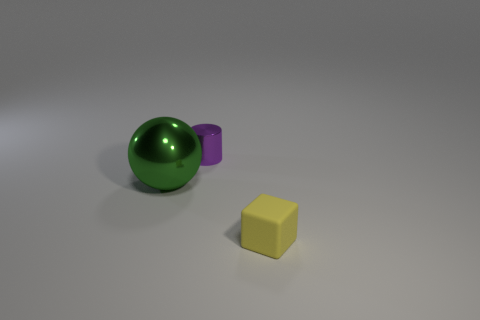Are there any other things that are the same shape as the big thing?
Your answer should be very brief. No. Are there fewer yellow matte objects that are behind the purple shiny cylinder than small green rubber spheres?
Ensure brevity in your answer.  No. How many small green objects are there?
Your answer should be very brief. 0. What number of big balls have the same material as the tiny purple thing?
Provide a succinct answer. 1. What number of things are metal objects that are to the right of the large green thing or tiny yellow rubber cubes?
Your response must be concise. 2. Is the number of tiny purple shiny objects in front of the green shiny thing less than the number of cylinders behind the yellow rubber thing?
Ensure brevity in your answer.  Yes. There is a big green metal ball; are there any yellow cubes behind it?
Your answer should be compact. No. What number of objects are small objects to the left of the matte block or objects behind the tiny rubber block?
Offer a terse response. 2. What is the shape of the thing that is behind the tiny rubber object and on the right side of the big green metallic ball?
Your answer should be very brief. Cylinder. Are there more large shiny things than large cyan cylinders?
Offer a terse response. Yes. 